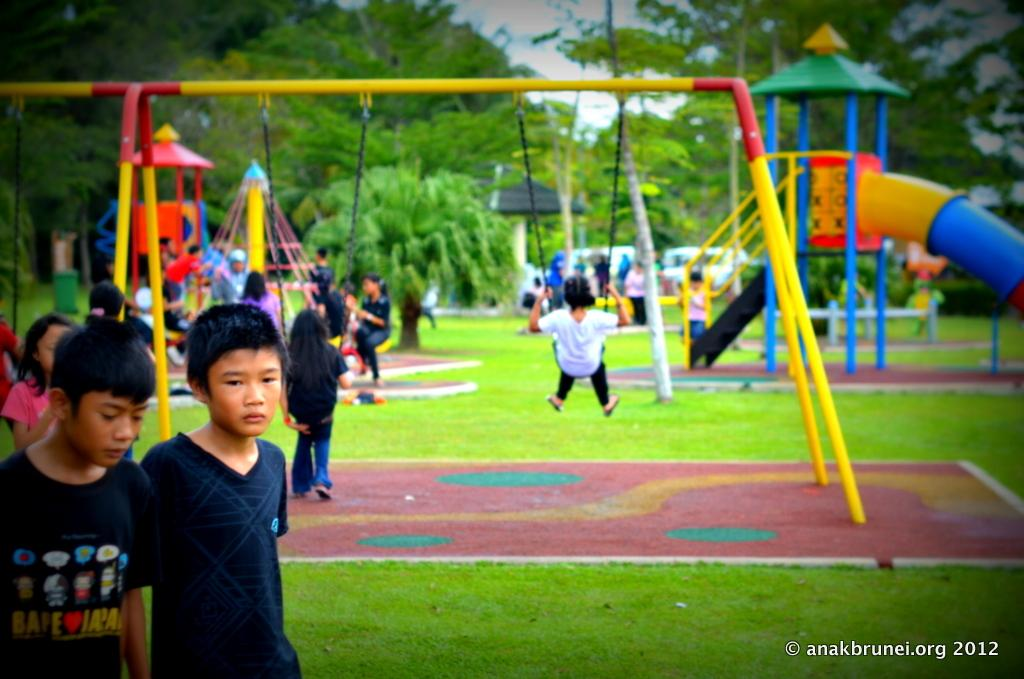Who is present in the image? There are children in the image. Where are the children located? The children are in a park. What can be seen in the park besides the children? There are playing equipments and trees in the park. What type of volleyball game is being played in the image? There is no volleyball game present in the image. How many times has the fifth-grade class visited the park in the image? There is no information about a specific class or visit in the image. 